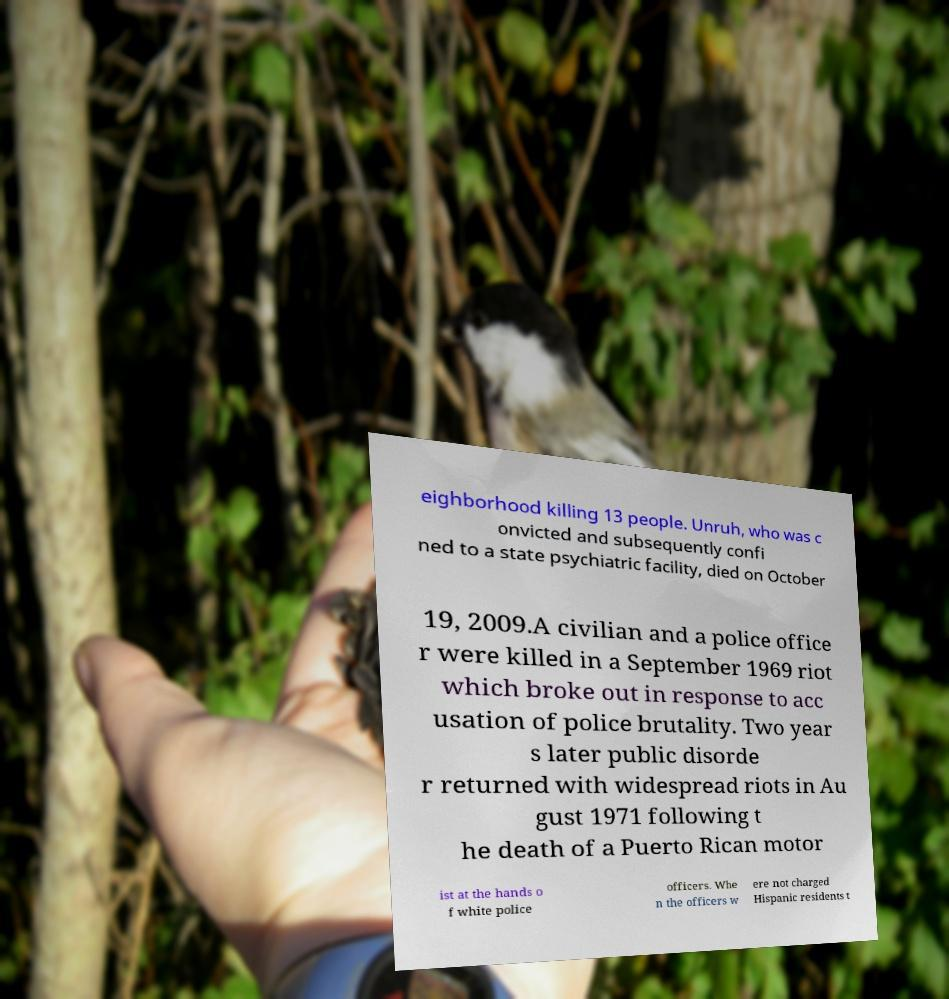Can you read and provide the text displayed in the image?This photo seems to have some interesting text. Can you extract and type it out for me? eighborhood killing 13 people. Unruh, who was c onvicted and subsequently confi ned to a state psychiatric facility, died on October 19, 2009.A civilian and a police office r were killed in a September 1969 riot which broke out in response to acc usation of police brutality. Two year s later public disorde r returned with widespread riots in Au gust 1971 following t he death of a Puerto Rican motor ist at the hands o f white police officers. Whe n the officers w ere not charged Hispanic residents t 